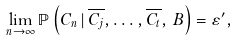<formula> <loc_0><loc_0><loc_500><loc_500>\lim _ { n \to \infty } { \mathbb { P } } \left ( C _ { n } \, | \, \overline { C _ { j } } , \dots , \overline { C _ { t } } , \, B \right ) = \varepsilon ^ { \prime } ,</formula> 